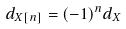Convert formula to latex. <formula><loc_0><loc_0><loc_500><loc_500>d _ { X [ n ] } = ( - 1 ) ^ { n } d _ { X }</formula> 